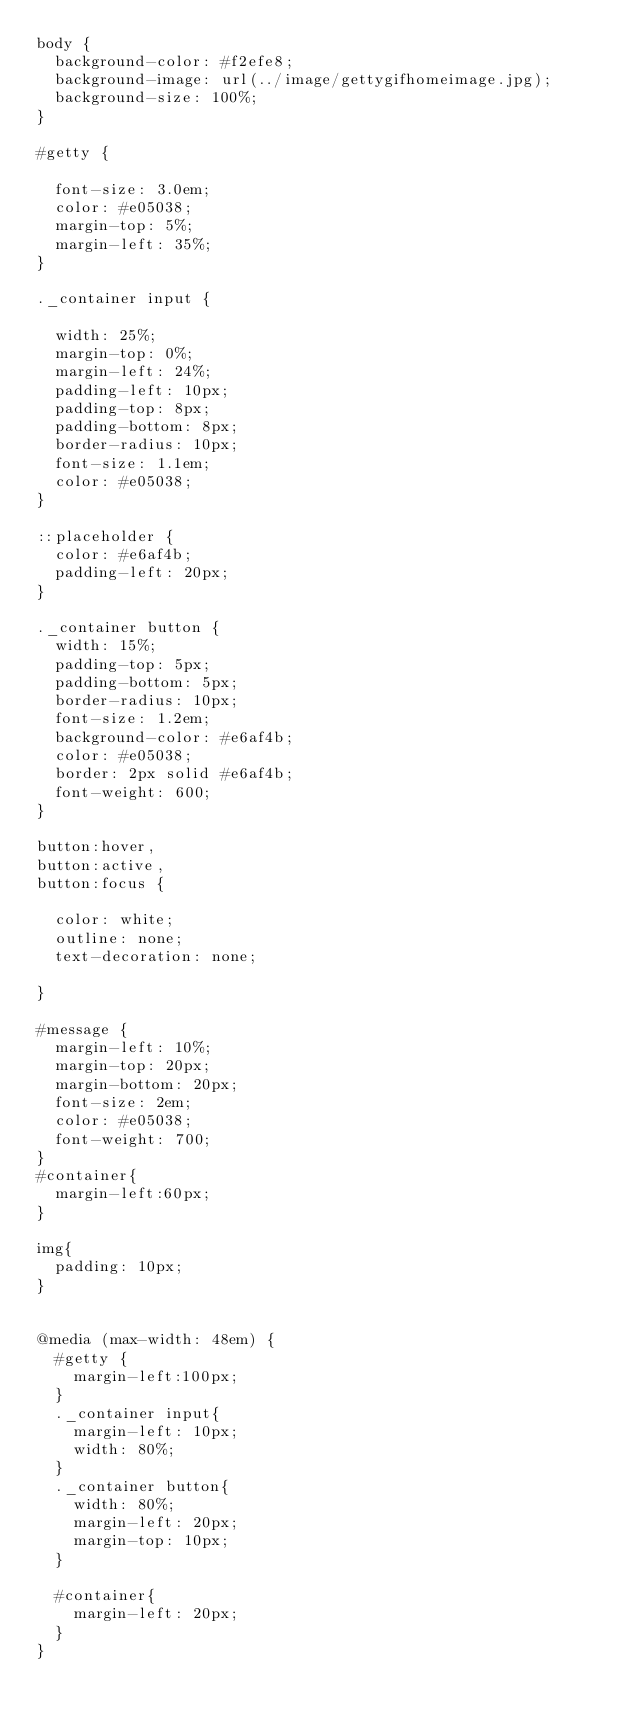Convert code to text. <code><loc_0><loc_0><loc_500><loc_500><_CSS_>body {
	background-color: #f2efe8;
	background-image: url(../image/gettygifhomeimage.jpg);
	background-size: 100%;
}

#getty {

	font-size: 3.0em;
	color: #e05038;
	margin-top: 5%;
	margin-left: 35%;
}

._container input {

	width: 25%;
	margin-top: 0%;
	margin-left: 24%;
	padding-left: 10px;
	padding-top: 8px;
	padding-bottom: 8px;
	border-radius: 10px;
	font-size: 1.1em;
	color: #e05038;
}

::placeholder {
	color: #e6af4b;
	padding-left: 20px;
}

._container button {
	width: 15%;
	padding-top: 5px;
	padding-bottom: 5px;
	border-radius: 10px;
	font-size: 1.2em;
	background-color: #e6af4b;
	color: #e05038;
	border: 2px solid #e6af4b;
	font-weight: 600;
}

button:hover,
button:active,
button:focus {
	
	color: white;
	outline: none;
	text-decoration: none;

}

#message {
	margin-left: 10%;
	margin-top: 20px;
	margin-bottom: 20px;
	font-size: 2em;
	color: #e05038;
	font-weight: 700;
}
#container{
	margin-left:60px;
}

img{
	padding: 10px;
}


@media (max-width: 48em) {
	#getty {
		margin-left:100px;
	}
	._container input{
		margin-left: 10px;
		width: 80%;
	}
	._container button{
		width: 80%;
		margin-left: 20px;
		margin-top: 10px;
	}
	
	#container{
		margin-left: 20px;
	}
}
</code> 